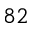<formula> <loc_0><loc_0><loc_500><loc_500>^ { 8 2 }</formula> 